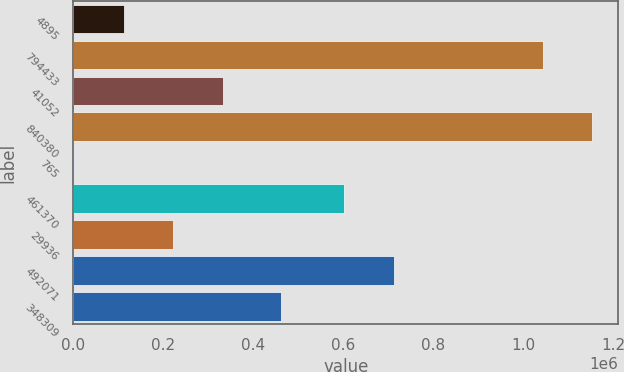Convert chart to OTSL. <chart><loc_0><loc_0><loc_500><loc_500><bar_chart><fcel>4895<fcel>794433<fcel>41052<fcel>840380<fcel>765<fcel>461370<fcel>29936<fcel>492071<fcel>348309<nl><fcel>111526<fcel>1.0428e+06<fcel>332859<fcel>1.15347e+06<fcel>860<fcel>601620<fcel>222193<fcel>712286<fcel>461394<nl></chart> 